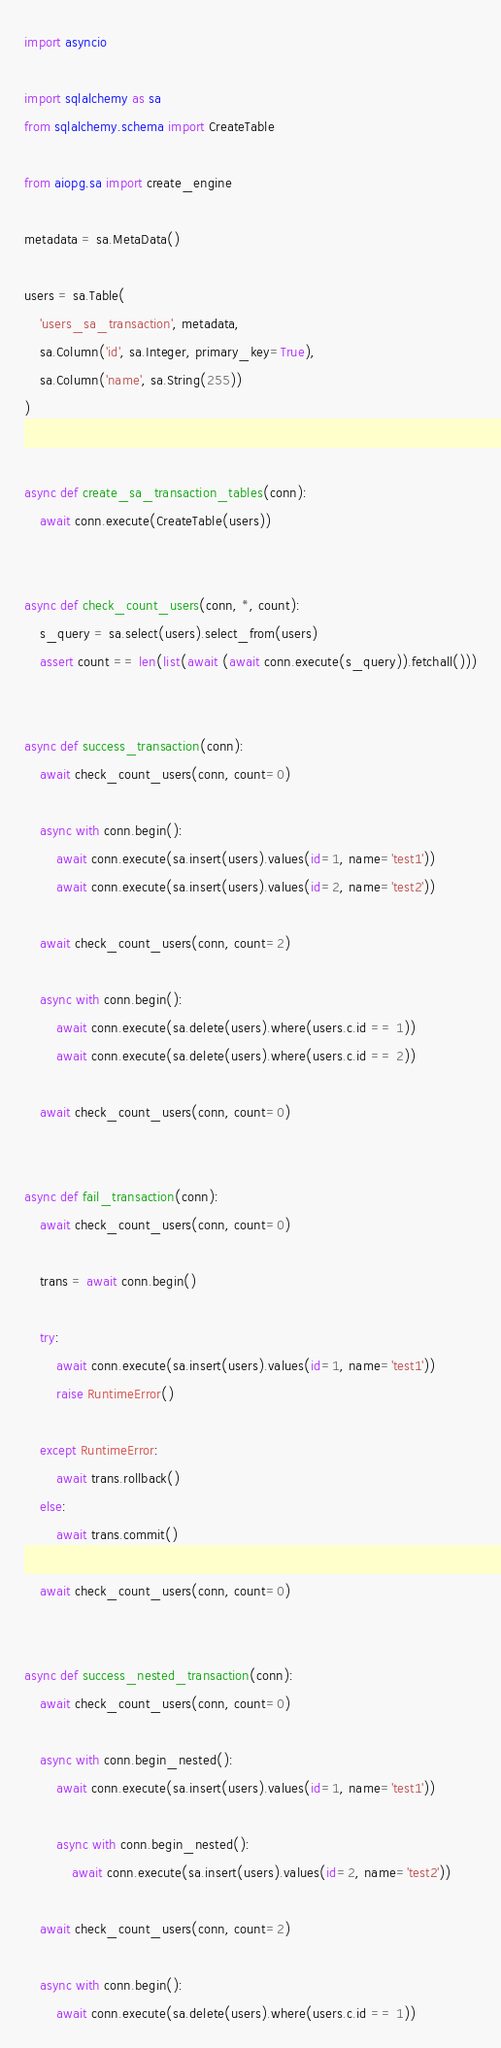<code> <loc_0><loc_0><loc_500><loc_500><_Python_>import asyncio

import sqlalchemy as sa
from sqlalchemy.schema import CreateTable

from aiopg.sa import create_engine

metadata = sa.MetaData()

users = sa.Table(
    'users_sa_transaction', metadata,
    sa.Column('id', sa.Integer, primary_key=True),
    sa.Column('name', sa.String(255))
)


async def create_sa_transaction_tables(conn):
    await conn.execute(CreateTable(users))


async def check_count_users(conn, *, count):
    s_query = sa.select(users).select_from(users)
    assert count == len(list(await (await conn.execute(s_query)).fetchall()))


async def success_transaction(conn):
    await check_count_users(conn, count=0)

    async with conn.begin():
        await conn.execute(sa.insert(users).values(id=1, name='test1'))
        await conn.execute(sa.insert(users).values(id=2, name='test2'))

    await check_count_users(conn, count=2)

    async with conn.begin():
        await conn.execute(sa.delete(users).where(users.c.id == 1))
        await conn.execute(sa.delete(users).where(users.c.id == 2))

    await check_count_users(conn, count=0)


async def fail_transaction(conn):
    await check_count_users(conn, count=0)

    trans = await conn.begin()

    try:
        await conn.execute(sa.insert(users).values(id=1, name='test1'))
        raise RuntimeError()

    except RuntimeError:
        await trans.rollback()
    else:
        await trans.commit()

    await check_count_users(conn, count=0)


async def success_nested_transaction(conn):
    await check_count_users(conn, count=0)

    async with conn.begin_nested():
        await conn.execute(sa.insert(users).values(id=1, name='test1'))

        async with conn.begin_nested():
            await conn.execute(sa.insert(users).values(id=2, name='test2'))

    await check_count_users(conn, count=2)

    async with conn.begin():
        await conn.execute(sa.delete(users).where(users.c.id == 1))</code> 